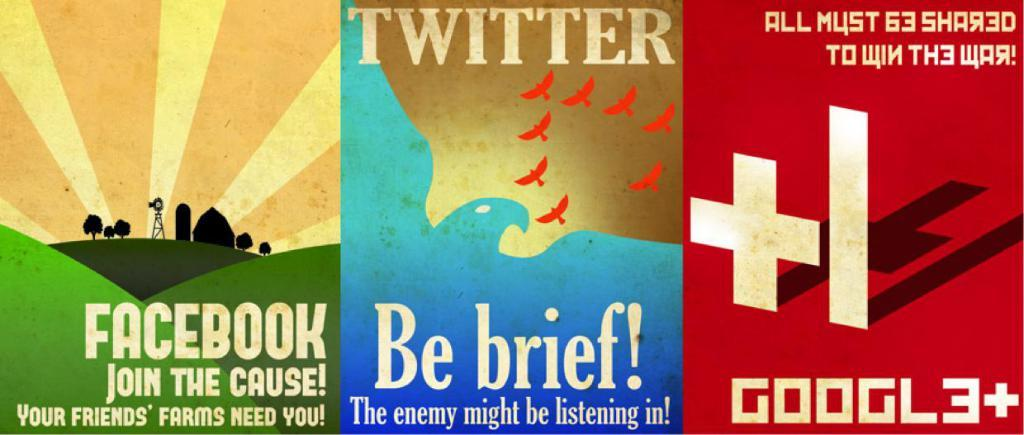<image>
Summarize the visual content of the image. Several colorful posters serving as advertisements for Facebook, Twitter, and Google+ 